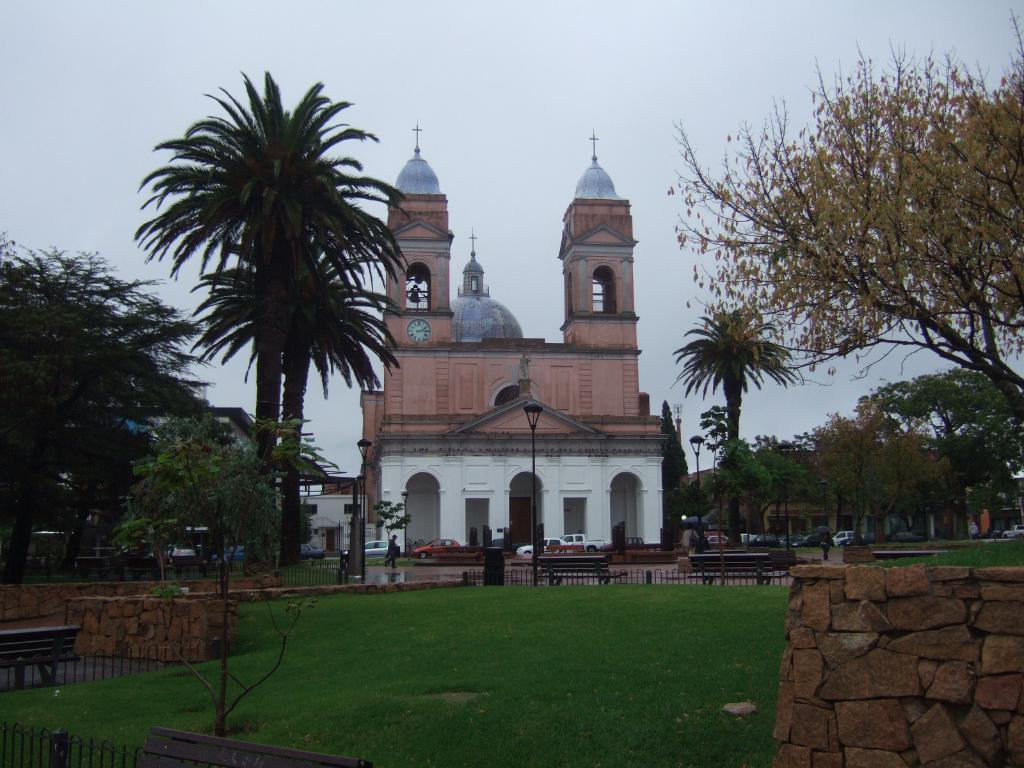What type of vegetation can be seen in the image? There is grass in the image. What structures are present in the image? There are fences, benches, walls, and buildings in the image. What mode of transportation can be seen in the image? There are vehicles in the image. What type of natural elements are present in the image? There are trees in the image. What artificial structures are present in the image? There are light poles in the image. Are there any living beings in the image? Yes, there are people in the image. What other objects can be seen in the image? There are objects in the image, but their specific nature is not mentioned. What can be seen in the background of the image? The sky is visible in the background of the image. Can you tell me how many bars of soap are on the benches in the image? There is no mention of soap in the image, so it is not possible to answer this question. 